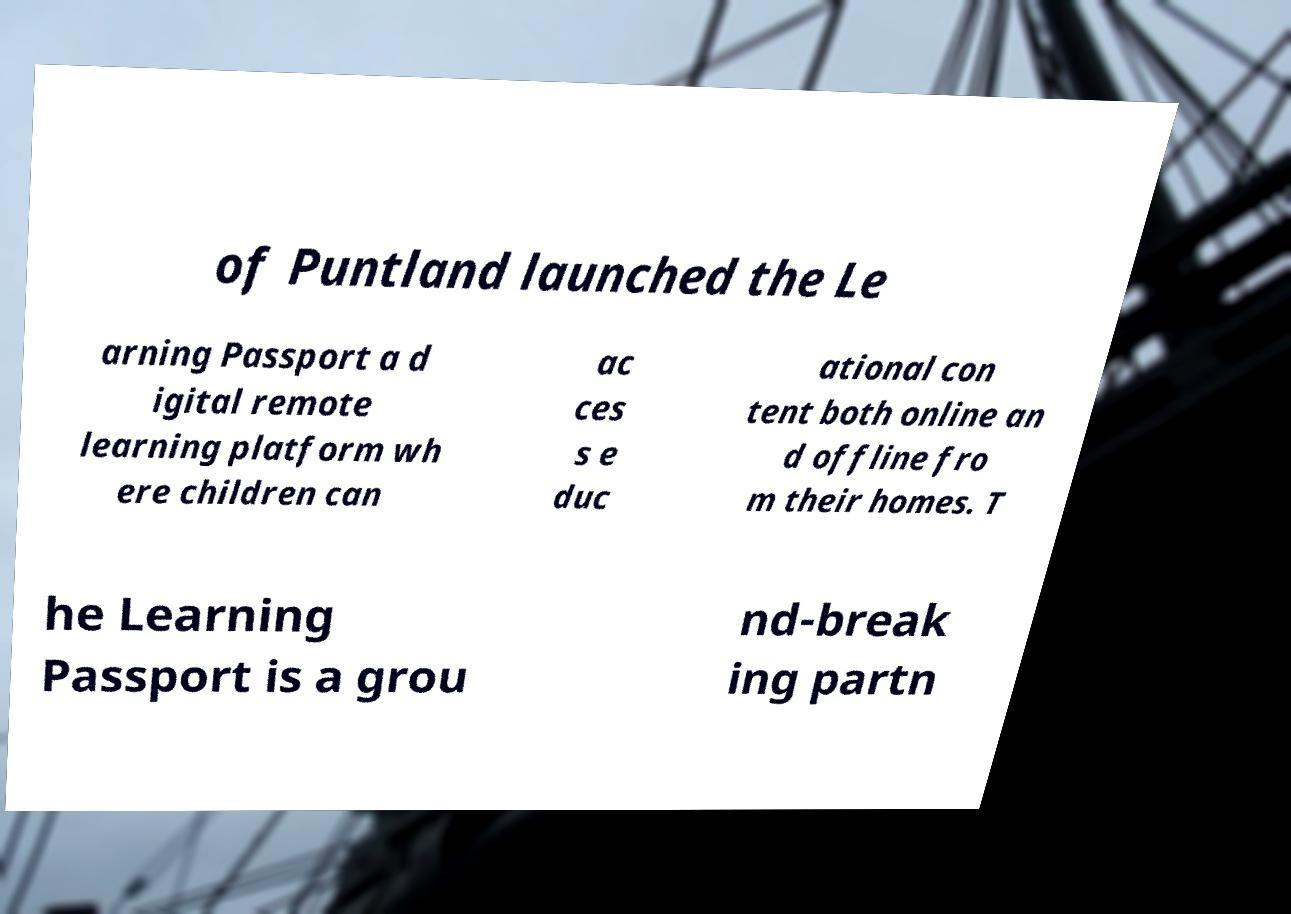Please read and relay the text visible in this image. What does it say? of Puntland launched the Le arning Passport a d igital remote learning platform wh ere children can ac ces s e duc ational con tent both online an d offline fro m their homes. T he Learning Passport is a grou nd-break ing partn 